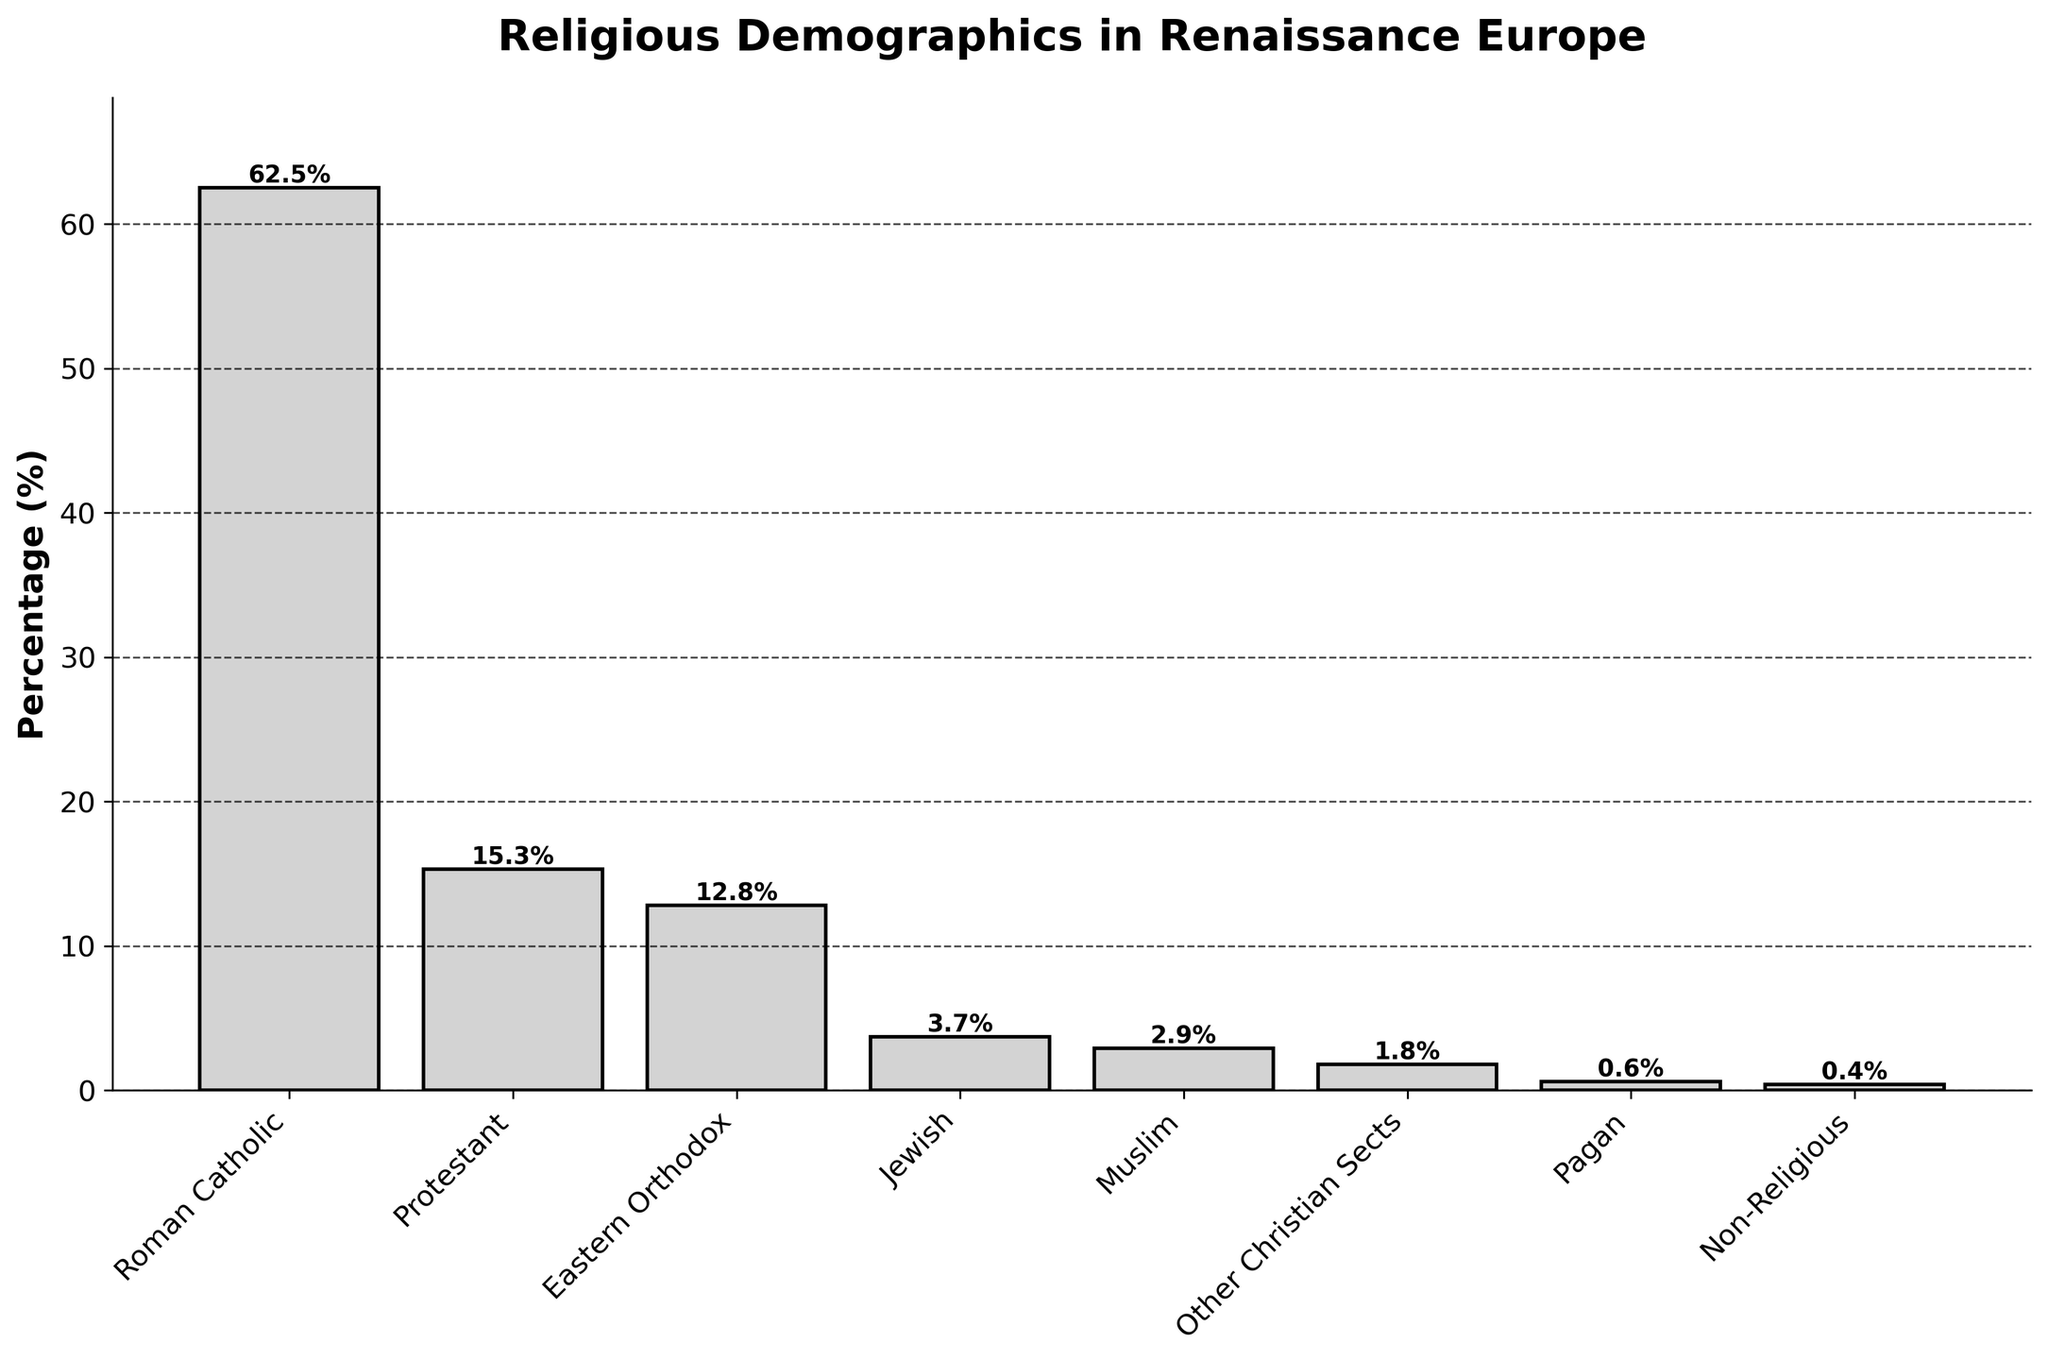How many religions listed have a percentage higher than 10%? From the bar chart, you can see the heights corresponding to various given percentages. The religions with percentages above 10% are Roman Catholic, Protestant, and Eastern Orthodox. By counting them, it's clear there are three such religions.
Answer: Three Which religion has the highest percentage? Observing the height of the bars in the bar chart and the labels, the highest bar represents the Roman Catholic percentage at 62.5%.
Answer: Roman Catholic What’s the combined percentage of Jewish, Muslim, and Non-Religious groups? Adding the percentages: Jewish (3.7%) + Muslim (2.9%) + Non-Religious (0.4%) = 3.7 + 2.9 + 0.4 = 7.0%.
Answer: 7.0% How much higher is the percentage of Roman Catholics compared to Protestants? The percentage for Roman Catholic is 62.5%, and for Protestant, it is 15.3%. Subtracting these gives 62.5 - 15.3 = 47.2.
Answer: 47.2% Which group has the smallest percentage and what is its value? From viewing the shortest bar and reading the label, the Pagan group has the smallest percentage at 0.6%.
Answer: Pagan, 0.6% How does the combined percentage of Eastern Orthodox and Protestant compare to Roman Catholic? Adding Eastern Orthodox (12.8%) and Protestant (15.3%) gives 12.8 + 15.3 = 28.1%. Roman Catholic alone is 62.5%. Hence, Roman Catholic is greater.
Answer: Roman Catholic is greater Estimate the total percentage represented by all Christian sects listed (Roman Catholic, Protestant, Eastern Orthodox, and Other Christian Sects). Summing up the percentages: Roman Catholic (62.5%) + Protestant (15.3%) + Eastern Orthodox (12.8%) + Other Christian Sects (1.8%) = 62.5 + 15.3 + 12.8 + 1.8 = 92.4%.
Answer: 92.4% Which religions have a percentage difference of less than 1%? By checking the bar lengths and values, Non-Religious (0.4%) and Pagan (0.6%) have a difference of 0.6 - 0.4 = 0.2%, and Other Christian Sects (1.8%) and Pagan (0.6%) have a difference of 1.2%. Only Non-Religious and Pagan meet the criteria.
Answer: Non-Religious and Pagan What proportion of the total percentage does the Muslim group represent? To find the proportion, divide the percentage of the Muslim group by 100: 2.9 / 100 = 0.029, which is approximately 2.9%.
Answer: 2.9% What percentage of the total religious demographics is Non-Christian based on the chart? Sum percentages for Non-Christian religions: Jewish (3.7%) + Muslim (2.9%) + Pagan (0.6%) + Non-Religious (0.4%) = 3.7 + 2.9 + 0.6 + 0.4 = 7.6%.
Answer: 7.6% 